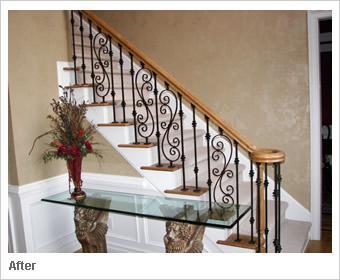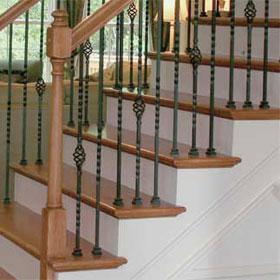The first image is the image on the left, the second image is the image on the right. Assess this claim about the two images: "Two staircases and bannisters curve as they go downstairs.". Correct or not? Answer yes or no. No. The first image is the image on the left, the second image is the image on the right. Given the left and right images, does the statement "there is a wood rail staircase with black iron rods and carpeted stairs" hold true? Answer yes or no. Yes. 